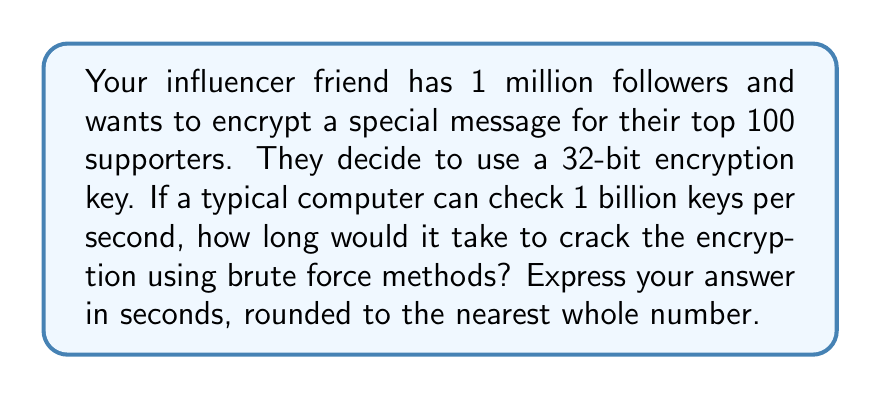Could you help me with this problem? Let's approach this step-by-step:

1. First, we need to calculate the total number of possible keys:
   For a 32-bit key, there are $2^{32}$ possible combinations.

2. Calculate the total number of keys:
   $$2^{32} = 4,294,967,296$$

3. Now, we know that the computer can check 1 billion keys per second:
   $1,000,000,000$ keys/second

4. To find the time required, we divide the total number of keys by the number of keys checked per second:

   $$\text{Time} = \frac{\text{Total keys}}{\text{Keys per second}} = \frac{4,294,967,296}{1,000,000,000}$$

5. Perform the division:
   $$\text{Time} = 4.294967296 \text{ seconds}$$

6. Rounding to the nearest whole number:
   $$\text{Time} \approx 4 \text{ seconds}$$
Answer: 4 seconds 